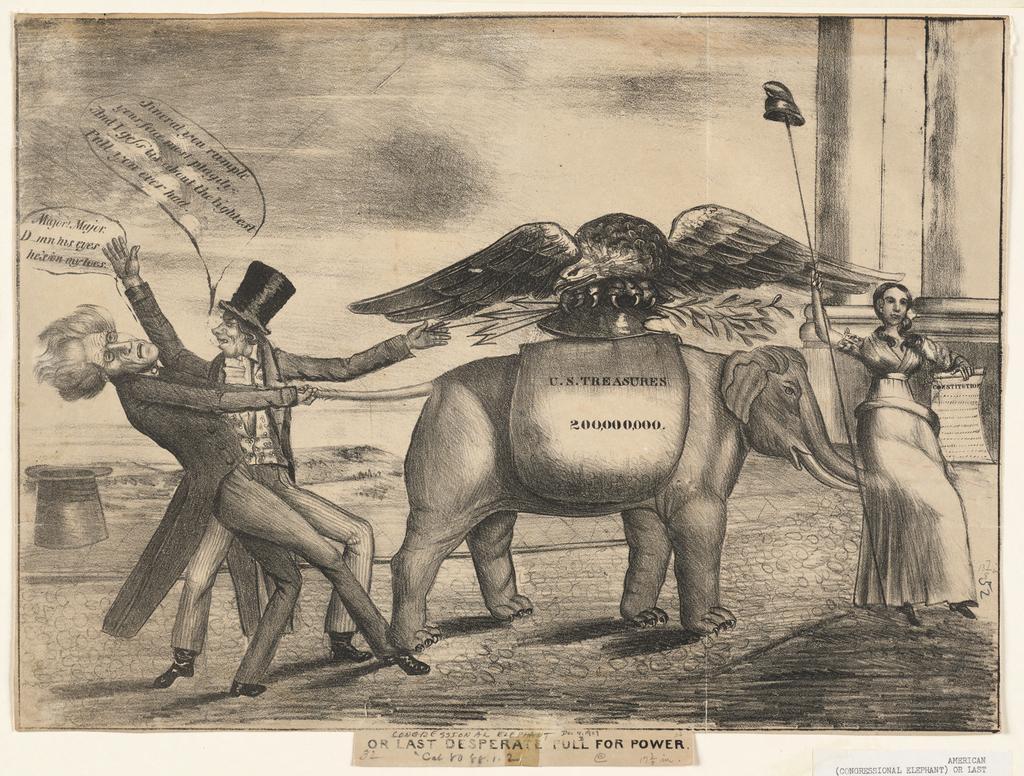How would you summarize this image in a sentence or two? This image consists of a poster with a text and a few images on it. In this image there is an elephant on the ground and a man is pulling elephant's tail. There is another man. On the right side of the image. 